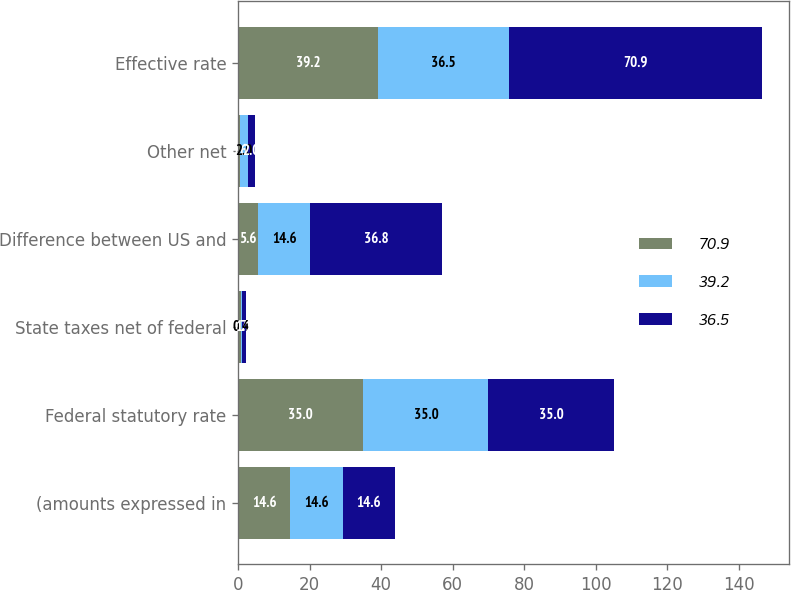Convert chart. <chart><loc_0><loc_0><loc_500><loc_500><stacked_bar_chart><ecel><fcel>(amounts expressed in<fcel>Federal statutory rate<fcel>State taxes net of federal<fcel>Difference between US and<fcel>Other net<fcel>Effective rate<nl><fcel>70.9<fcel>14.6<fcel>35<fcel>0.7<fcel>5.6<fcel>0.6<fcel>39.2<nl><fcel>39.2<fcel>14.6<fcel>35<fcel>0.4<fcel>14.6<fcel>2<fcel>36.5<nl><fcel>36.5<fcel>14.6<fcel>35<fcel>1.1<fcel>36.8<fcel>2<fcel>70.9<nl></chart> 